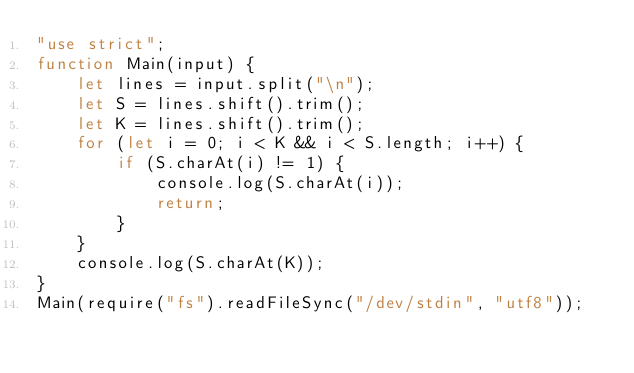Convert code to text. <code><loc_0><loc_0><loc_500><loc_500><_JavaScript_>"use strict";
function Main(input) {
    let lines = input.split("\n");
    let S = lines.shift().trim();
    let K = lines.shift().trim();
    for (let i = 0; i < K && i < S.length; i++) {
        if (S.charAt(i) != 1) {
            console.log(S.charAt(i));
            return;
        }
    }
    console.log(S.charAt(K));
}
Main(require("fs").readFileSync("/dev/stdin", "utf8"));</code> 